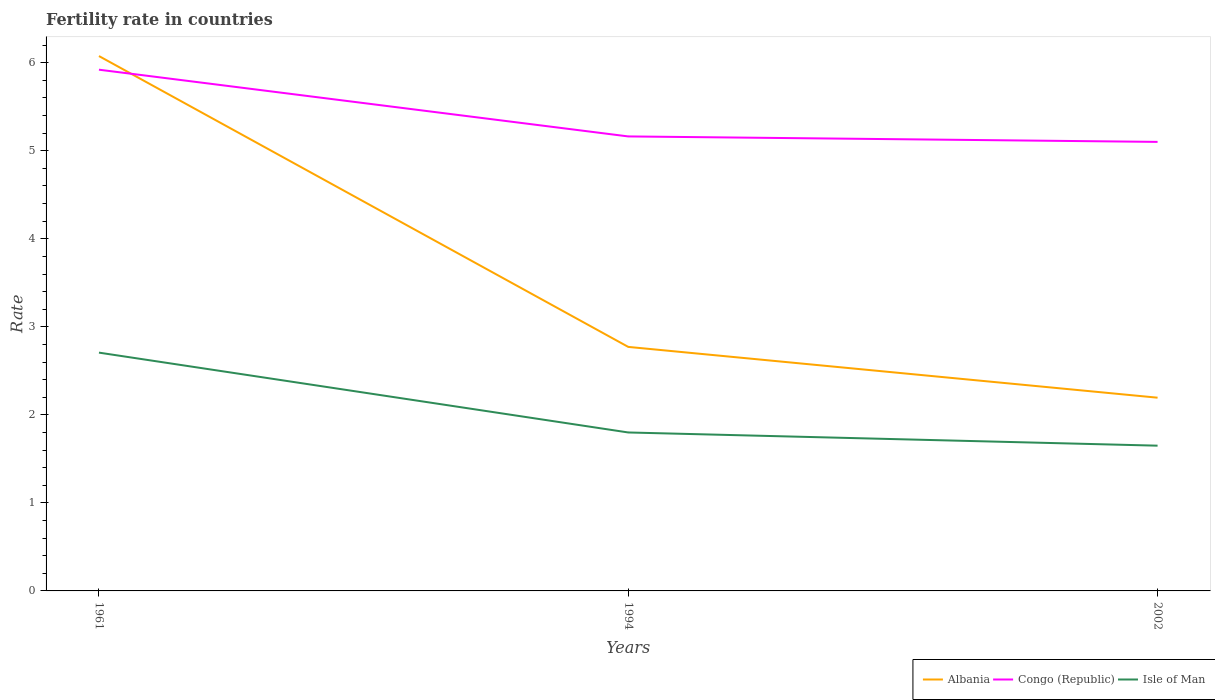How many different coloured lines are there?
Your answer should be very brief. 3. Is the number of lines equal to the number of legend labels?
Make the answer very short. Yes. Across all years, what is the maximum fertility rate in Albania?
Your response must be concise. 2.19. In which year was the fertility rate in Albania maximum?
Ensure brevity in your answer.  2002. What is the total fertility rate in Albania in the graph?
Your answer should be compact. 3.88. What is the difference between the highest and the second highest fertility rate in Congo (Republic)?
Offer a very short reply. 0.82. What is the difference between the highest and the lowest fertility rate in Isle of Man?
Provide a succinct answer. 1. How many years are there in the graph?
Make the answer very short. 3. Are the values on the major ticks of Y-axis written in scientific E-notation?
Keep it short and to the point. No. How are the legend labels stacked?
Provide a succinct answer. Horizontal. What is the title of the graph?
Provide a short and direct response. Fertility rate in countries. Does "Ethiopia" appear as one of the legend labels in the graph?
Offer a terse response. No. What is the label or title of the Y-axis?
Your answer should be very brief. Rate. What is the Rate in Albania in 1961?
Provide a succinct answer. 6.08. What is the Rate of Congo (Republic) in 1961?
Offer a very short reply. 5.92. What is the Rate in Isle of Man in 1961?
Keep it short and to the point. 2.71. What is the Rate of Albania in 1994?
Keep it short and to the point. 2.77. What is the Rate of Congo (Republic) in 1994?
Give a very brief answer. 5.16. What is the Rate in Isle of Man in 1994?
Keep it short and to the point. 1.8. What is the Rate of Albania in 2002?
Make the answer very short. 2.19. What is the Rate in Congo (Republic) in 2002?
Provide a succinct answer. 5.1. What is the Rate in Isle of Man in 2002?
Give a very brief answer. 1.65. Across all years, what is the maximum Rate in Albania?
Make the answer very short. 6.08. Across all years, what is the maximum Rate of Congo (Republic)?
Make the answer very short. 5.92. Across all years, what is the maximum Rate of Isle of Man?
Provide a succinct answer. 2.71. Across all years, what is the minimum Rate in Albania?
Ensure brevity in your answer.  2.19. Across all years, what is the minimum Rate in Congo (Republic)?
Offer a very short reply. 5.1. Across all years, what is the minimum Rate of Isle of Man?
Your answer should be very brief. 1.65. What is the total Rate of Albania in the graph?
Your answer should be very brief. 11.04. What is the total Rate in Congo (Republic) in the graph?
Keep it short and to the point. 16.18. What is the total Rate in Isle of Man in the graph?
Your answer should be compact. 6.16. What is the difference between the Rate of Albania in 1961 and that in 1994?
Offer a very short reply. 3.3. What is the difference between the Rate in Congo (Republic) in 1961 and that in 1994?
Keep it short and to the point. 0.76. What is the difference between the Rate of Isle of Man in 1961 and that in 1994?
Provide a succinct answer. 0.91. What is the difference between the Rate in Albania in 1961 and that in 2002?
Give a very brief answer. 3.88. What is the difference between the Rate in Congo (Republic) in 1961 and that in 2002?
Offer a terse response. 0.82. What is the difference between the Rate of Isle of Man in 1961 and that in 2002?
Offer a very short reply. 1.06. What is the difference between the Rate of Albania in 1994 and that in 2002?
Make the answer very short. 0.58. What is the difference between the Rate of Congo (Republic) in 1994 and that in 2002?
Provide a succinct answer. 0.06. What is the difference between the Rate in Isle of Man in 1994 and that in 2002?
Your response must be concise. 0.15. What is the difference between the Rate of Albania in 1961 and the Rate of Isle of Man in 1994?
Your response must be concise. 4.28. What is the difference between the Rate in Congo (Republic) in 1961 and the Rate in Isle of Man in 1994?
Provide a succinct answer. 4.12. What is the difference between the Rate in Albania in 1961 and the Rate in Isle of Man in 2002?
Offer a terse response. 4.43. What is the difference between the Rate in Congo (Republic) in 1961 and the Rate in Isle of Man in 2002?
Ensure brevity in your answer.  4.27. What is the difference between the Rate of Albania in 1994 and the Rate of Congo (Republic) in 2002?
Your response must be concise. -2.33. What is the difference between the Rate in Albania in 1994 and the Rate in Isle of Man in 2002?
Your response must be concise. 1.12. What is the difference between the Rate in Congo (Republic) in 1994 and the Rate in Isle of Man in 2002?
Offer a very short reply. 3.51. What is the average Rate of Albania per year?
Keep it short and to the point. 3.68. What is the average Rate of Congo (Republic) per year?
Offer a terse response. 5.39. What is the average Rate in Isle of Man per year?
Ensure brevity in your answer.  2.05. In the year 1961, what is the difference between the Rate of Albania and Rate of Congo (Republic)?
Offer a terse response. 0.15. In the year 1961, what is the difference between the Rate of Albania and Rate of Isle of Man?
Ensure brevity in your answer.  3.37. In the year 1961, what is the difference between the Rate in Congo (Republic) and Rate in Isle of Man?
Offer a terse response. 3.21. In the year 1994, what is the difference between the Rate of Albania and Rate of Congo (Republic)?
Ensure brevity in your answer.  -2.39. In the year 1994, what is the difference between the Rate in Congo (Republic) and Rate in Isle of Man?
Offer a very short reply. 3.36. In the year 2002, what is the difference between the Rate in Albania and Rate in Congo (Republic)?
Give a very brief answer. -2.91. In the year 2002, what is the difference between the Rate in Albania and Rate in Isle of Man?
Give a very brief answer. 0.55. In the year 2002, what is the difference between the Rate in Congo (Republic) and Rate in Isle of Man?
Ensure brevity in your answer.  3.45. What is the ratio of the Rate in Albania in 1961 to that in 1994?
Provide a short and direct response. 2.19. What is the ratio of the Rate in Congo (Republic) in 1961 to that in 1994?
Ensure brevity in your answer.  1.15. What is the ratio of the Rate of Isle of Man in 1961 to that in 1994?
Make the answer very short. 1.5. What is the ratio of the Rate in Albania in 1961 to that in 2002?
Your response must be concise. 2.77. What is the ratio of the Rate in Congo (Republic) in 1961 to that in 2002?
Provide a succinct answer. 1.16. What is the ratio of the Rate of Isle of Man in 1961 to that in 2002?
Offer a very short reply. 1.64. What is the ratio of the Rate of Albania in 1994 to that in 2002?
Give a very brief answer. 1.26. What is the ratio of the Rate in Congo (Republic) in 1994 to that in 2002?
Your answer should be very brief. 1.01. What is the difference between the highest and the second highest Rate of Albania?
Your answer should be compact. 3.3. What is the difference between the highest and the second highest Rate in Congo (Republic)?
Ensure brevity in your answer.  0.76. What is the difference between the highest and the second highest Rate of Isle of Man?
Make the answer very short. 0.91. What is the difference between the highest and the lowest Rate of Albania?
Ensure brevity in your answer.  3.88. What is the difference between the highest and the lowest Rate of Congo (Republic)?
Your answer should be very brief. 0.82. What is the difference between the highest and the lowest Rate in Isle of Man?
Ensure brevity in your answer.  1.06. 